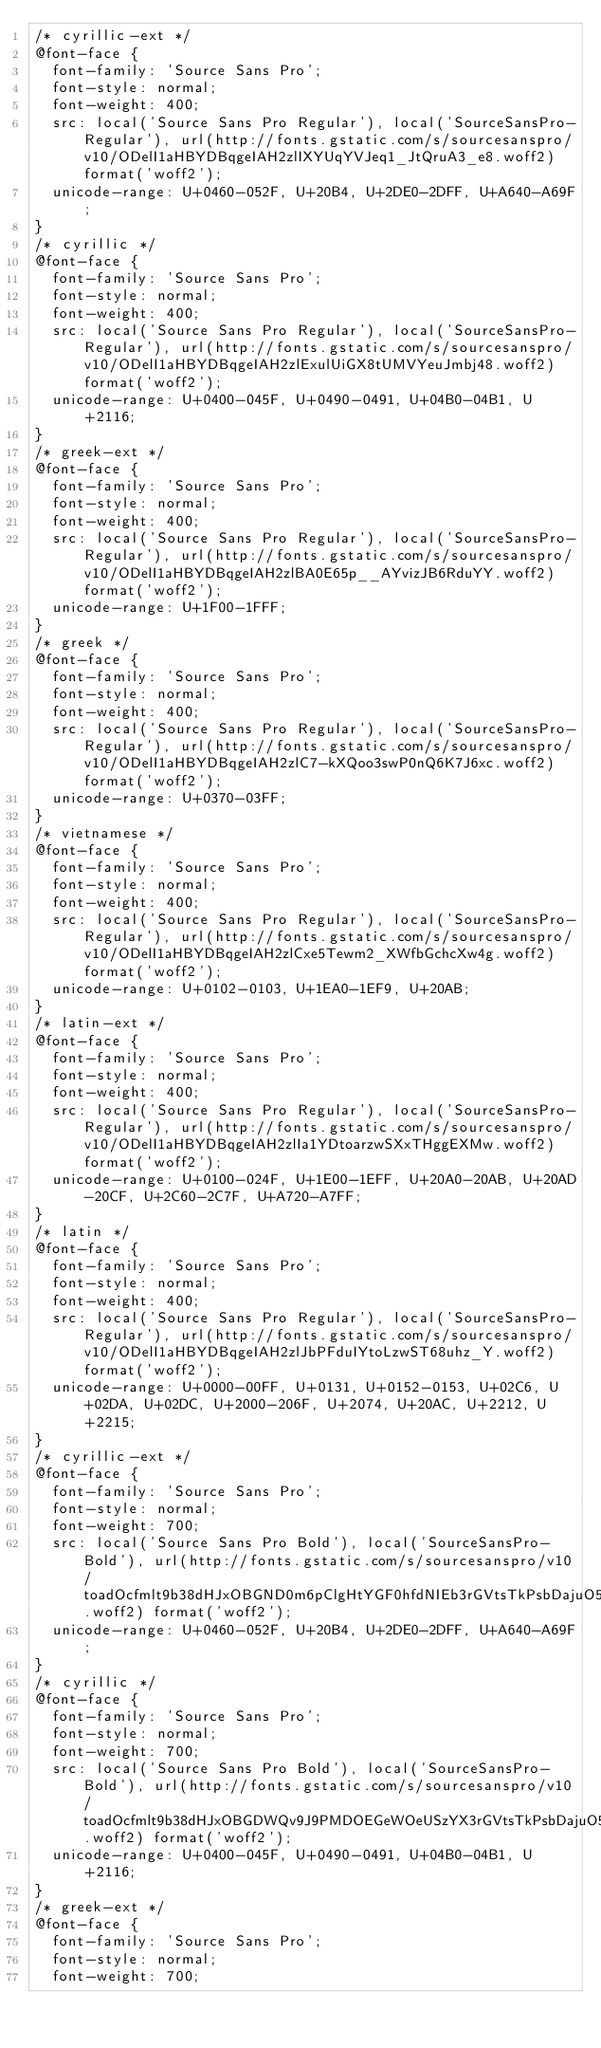Convert code to text. <code><loc_0><loc_0><loc_500><loc_500><_CSS_>/* cyrillic-ext */
@font-face {
  font-family: 'Source Sans Pro';
  font-style: normal;
  font-weight: 400;
  src: local('Source Sans Pro Regular'), local('SourceSansPro-Regular'), url(http://fonts.gstatic.com/s/sourcesanspro/v10/ODelI1aHBYDBqgeIAH2zlIXYUqYVJeq1_JtQruA3_e8.woff2) format('woff2');
  unicode-range: U+0460-052F, U+20B4, U+2DE0-2DFF, U+A640-A69F;
}
/* cyrillic */
@font-face {
  font-family: 'Source Sans Pro';
  font-style: normal;
  font-weight: 400;
  src: local('Source Sans Pro Regular'), local('SourceSansPro-Regular'), url(http://fonts.gstatic.com/s/sourcesanspro/v10/ODelI1aHBYDBqgeIAH2zlExulUiGX8tUMVYeuJmbj48.woff2) format('woff2');
  unicode-range: U+0400-045F, U+0490-0491, U+04B0-04B1, U+2116;
}
/* greek-ext */
@font-face {
  font-family: 'Source Sans Pro';
  font-style: normal;
  font-weight: 400;
  src: local('Source Sans Pro Regular'), local('SourceSansPro-Regular'), url(http://fonts.gstatic.com/s/sourcesanspro/v10/ODelI1aHBYDBqgeIAH2zlBA0E65p__AYvizJB6RduYY.woff2) format('woff2');
  unicode-range: U+1F00-1FFF;
}
/* greek */
@font-face {
  font-family: 'Source Sans Pro';
  font-style: normal;
  font-weight: 400;
  src: local('Source Sans Pro Regular'), local('SourceSansPro-Regular'), url(http://fonts.gstatic.com/s/sourcesanspro/v10/ODelI1aHBYDBqgeIAH2zlC7-kXQoo3swP0nQ6K7J6xc.woff2) format('woff2');
  unicode-range: U+0370-03FF;
}
/* vietnamese */
@font-face {
  font-family: 'Source Sans Pro';
  font-style: normal;
  font-weight: 400;
  src: local('Source Sans Pro Regular'), local('SourceSansPro-Regular'), url(http://fonts.gstatic.com/s/sourcesanspro/v10/ODelI1aHBYDBqgeIAH2zlCxe5Tewm2_XWfbGchcXw4g.woff2) format('woff2');
  unicode-range: U+0102-0103, U+1EA0-1EF9, U+20AB;
}
/* latin-ext */
@font-face {
  font-family: 'Source Sans Pro';
  font-style: normal;
  font-weight: 400;
  src: local('Source Sans Pro Regular'), local('SourceSansPro-Regular'), url(http://fonts.gstatic.com/s/sourcesanspro/v10/ODelI1aHBYDBqgeIAH2zlIa1YDtoarzwSXxTHggEXMw.woff2) format('woff2');
  unicode-range: U+0100-024F, U+1E00-1EFF, U+20A0-20AB, U+20AD-20CF, U+2C60-2C7F, U+A720-A7FF;
}
/* latin */
@font-face {
  font-family: 'Source Sans Pro';
  font-style: normal;
  font-weight: 400;
  src: local('Source Sans Pro Regular'), local('SourceSansPro-Regular'), url(http://fonts.gstatic.com/s/sourcesanspro/v10/ODelI1aHBYDBqgeIAH2zlJbPFduIYtoLzwST68uhz_Y.woff2) format('woff2');
  unicode-range: U+0000-00FF, U+0131, U+0152-0153, U+02C6, U+02DA, U+02DC, U+2000-206F, U+2074, U+20AC, U+2212, U+2215;
}
/* cyrillic-ext */
@font-face {
  font-family: 'Source Sans Pro';
  font-style: normal;
  font-weight: 700;
  src: local('Source Sans Pro Bold'), local('SourceSansPro-Bold'), url(http://fonts.gstatic.com/s/sourcesanspro/v10/toadOcfmlt9b38dHJxOBGND0m6pClgHtYGF0hfdNIEb3rGVtsTkPsbDajuO5ueQw.woff2) format('woff2');
  unicode-range: U+0460-052F, U+20B4, U+2DE0-2DFF, U+A640-A69F;
}
/* cyrillic */
@font-face {
  font-family: 'Source Sans Pro';
  font-style: normal;
  font-weight: 700;
  src: local('Source Sans Pro Bold'), local('SourceSansPro-Bold'), url(http://fonts.gstatic.com/s/sourcesanspro/v10/toadOcfmlt9b38dHJxOBGDWQv9J9PMDOEGeWOeUSzYX3rGVtsTkPsbDajuO5ueQw.woff2) format('woff2');
  unicode-range: U+0400-045F, U+0490-0491, U+04B0-04B1, U+2116;
}
/* greek-ext */
@font-face {
  font-family: 'Source Sans Pro';
  font-style: normal;
  font-weight: 700;</code> 